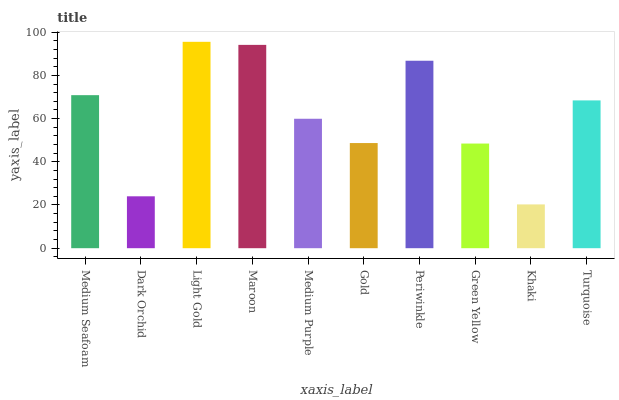Is Khaki the minimum?
Answer yes or no. Yes. Is Light Gold the maximum?
Answer yes or no. Yes. Is Dark Orchid the minimum?
Answer yes or no. No. Is Dark Orchid the maximum?
Answer yes or no. No. Is Medium Seafoam greater than Dark Orchid?
Answer yes or no. Yes. Is Dark Orchid less than Medium Seafoam?
Answer yes or no. Yes. Is Dark Orchid greater than Medium Seafoam?
Answer yes or no. No. Is Medium Seafoam less than Dark Orchid?
Answer yes or no. No. Is Turquoise the high median?
Answer yes or no. Yes. Is Medium Purple the low median?
Answer yes or no. Yes. Is Khaki the high median?
Answer yes or no. No. Is Turquoise the low median?
Answer yes or no. No. 